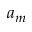<formula> <loc_0><loc_0><loc_500><loc_500>a _ { m }</formula> 